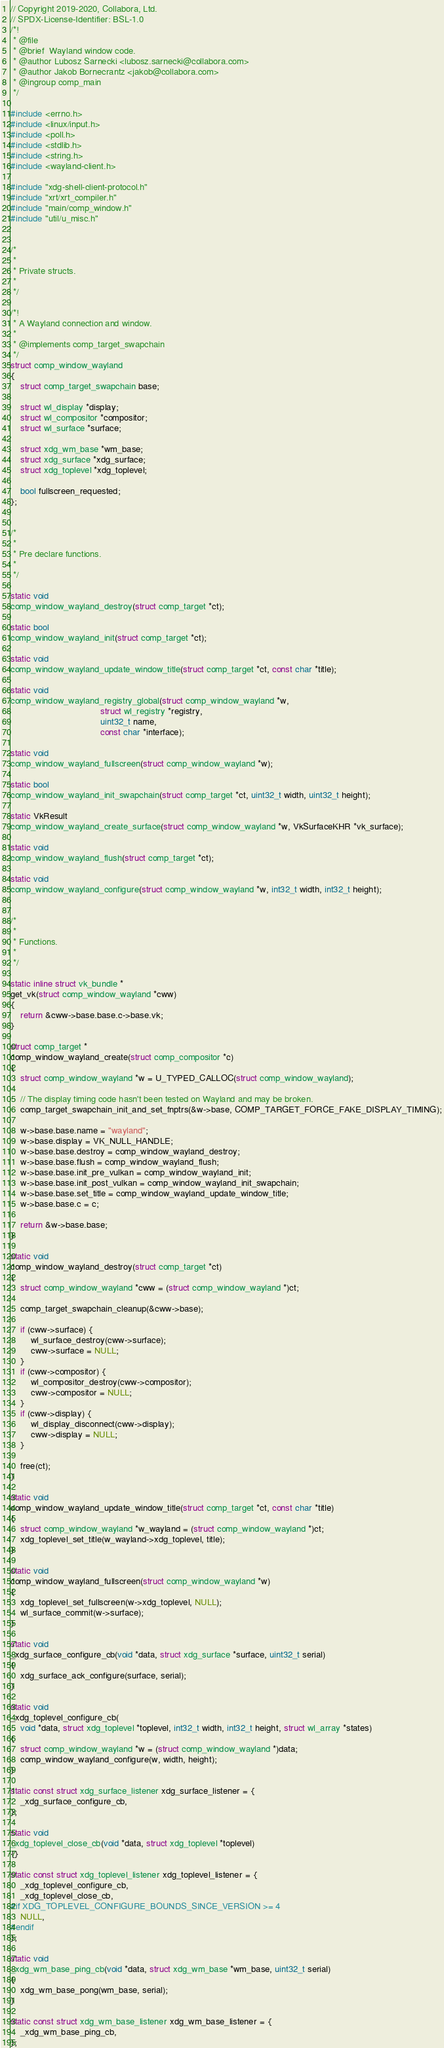<code> <loc_0><loc_0><loc_500><loc_500><_C_>// Copyright 2019-2020, Collabora, Ltd.
// SPDX-License-Identifier: BSL-1.0
/*!
 * @file
 * @brief  Wayland window code.
 * @author Lubosz Sarnecki <lubosz.sarnecki@collabora.com>
 * @author Jakob Bornecrantz <jakob@collabora.com>
 * @ingroup comp_main
 */

#include <errno.h>
#include <linux/input.h>
#include <poll.h>
#include <stdlib.h>
#include <string.h>
#include <wayland-client.h>

#include "xdg-shell-client-protocol.h"
#include "xrt/xrt_compiler.h"
#include "main/comp_window.h"
#include "util/u_misc.h"


/*
 *
 * Private structs.
 *
 */

/*!
 * A Wayland connection and window.
 *
 * @implements comp_target_swapchain
 */
struct comp_window_wayland
{
	struct comp_target_swapchain base;

	struct wl_display *display;
	struct wl_compositor *compositor;
	struct wl_surface *surface;

	struct xdg_wm_base *wm_base;
	struct xdg_surface *xdg_surface;
	struct xdg_toplevel *xdg_toplevel;

	bool fullscreen_requested;
};


/*
 *
 * Pre declare functions.
 *
 */

static void
comp_window_wayland_destroy(struct comp_target *ct);

static bool
comp_window_wayland_init(struct comp_target *ct);

static void
comp_window_wayland_update_window_title(struct comp_target *ct, const char *title);

static void
comp_window_wayland_registry_global(struct comp_window_wayland *w,
                                    struct wl_registry *registry,
                                    uint32_t name,
                                    const char *interface);

static void
comp_window_wayland_fullscreen(struct comp_window_wayland *w);

static bool
comp_window_wayland_init_swapchain(struct comp_target *ct, uint32_t width, uint32_t height);

static VkResult
comp_window_wayland_create_surface(struct comp_window_wayland *w, VkSurfaceKHR *vk_surface);

static void
comp_window_wayland_flush(struct comp_target *ct);

static void
comp_window_wayland_configure(struct comp_window_wayland *w, int32_t width, int32_t height);


/*
 *
 * Functions.
 *
 */

static inline struct vk_bundle *
get_vk(struct comp_window_wayland *cww)
{
	return &cww->base.base.c->base.vk;
}

struct comp_target *
comp_window_wayland_create(struct comp_compositor *c)
{
	struct comp_window_wayland *w = U_TYPED_CALLOC(struct comp_window_wayland);

	// The display timing code hasn't been tested on Wayland and may be broken.
	comp_target_swapchain_init_and_set_fnptrs(&w->base, COMP_TARGET_FORCE_FAKE_DISPLAY_TIMING);

	w->base.base.name = "wayland";
	w->base.display = VK_NULL_HANDLE;
	w->base.base.destroy = comp_window_wayland_destroy;
	w->base.base.flush = comp_window_wayland_flush;
	w->base.base.init_pre_vulkan = comp_window_wayland_init;
	w->base.base.init_post_vulkan = comp_window_wayland_init_swapchain;
	w->base.base.set_title = comp_window_wayland_update_window_title;
	w->base.base.c = c;

	return &w->base.base;
}

static void
comp_window_wayland_destroy(struct comp_target *ct)
{
	struct comp_window_wayland *cww = (struct comp_window_wayland *)ct;

	comp_target_swapchain_cleanup(&cww->base);

	if (cww->surface) {
		wl_surface_destroy(cww->surface);
		cww->surface = NULL;
	}
	if (cww->compositor) {
		wl_compositor_destroy(cww->compositor);
		cww->compositor = NULL;
	}
	if (cww->display) {
		wl_display_disconnect(cww->display);
		cww->display = NULL;
	}

	free(ct);
}

static void
comp_window_wayland_update_window_title(struct comp_target *ct, const char *title)
{
	struct comp_window_wayland *w_wayland = (struct comp_window_wayland *)ct;
	xdg_toplevel_set_title(w_wayland->xdg_toplevel, title);
}

static void
comp_window_wayland_fullscreen(struct comp_window_wayland *w)
{
	xdg_toplevel_set_fullscreen(w->xdg_toplevel, NULL);
	wl_surface_commit(w->surface);
}

static void
_xdg_surface_configure_cb(void *data, struct xdg_surface *surface, uint32_t serial)
{
	xdg_surface_ack_configure(surface, serial);
}

static void
_xdg_toplevel_configure_cb(
    void *data, struct xdg_toplevel *toplevel, int32_t width, int32_t height, struct wl_array *states)
{
	struct comp_window_wayland *w = (struct comp_window_wayland *)data;
	comp_window_wayland_configure(w, width, height);
}

static const struct xdg_surface_listener xdg_surface_listener = {
    _xdg_surface_configure_cb,
};

static void
_xdg_toplevel_close_cb(void *data, struct xdg_toplevel *toplevel)
{}

static const struct xdg_toplevel_listener xdg_toplevel_listener = {
    _xdg_toplevel_configure_cb,
    _xdg_toplevel_close_cb,
#if XDG_TOPLEVEL_CONFIGURE_BOUNDS_SINCE_VERSION >= 4
    NULL,
#endif
};

static void
_xdg_wm_base_ping_cb(void *data, struct xdg_wm_base *wm_base, uint32_t serial)
{
	xdg_wm_base_pong(wm_base, serial);
}

static const struct xdg_wm_base_listener xdg_wm_base_listener = {
    _xdg_wm_base_ping_cb,
};
</code> 